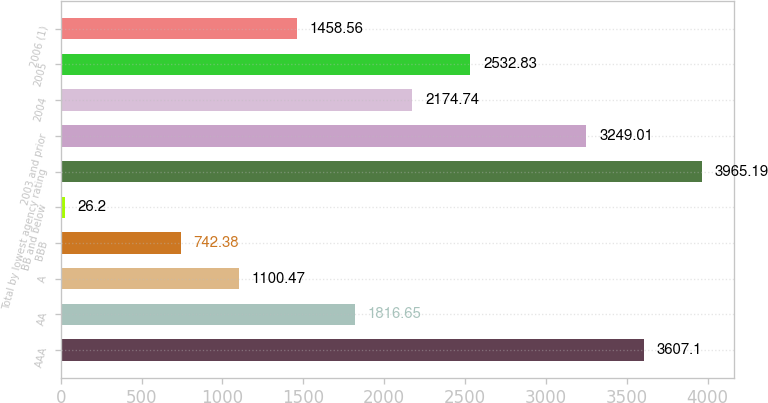<chart> <loc_0><loc_0><loc_500><loc_500><bar_chart><fcel>AAA<fcel>AA<fcel>A<fcel>BBB<fcel>BB and below<fcel>Total by lowest agency rating<fcel>2003 and prior<fcel>2004<fcel>2005<fcel>2006 (1)<nl><fcel>3607.1<fcel>1816.65<fcel>1100.47<fcel>742.38<fcel>26.2<fcel>3965.19<fcel>3249.01<fcel>2174.74<fcel>2532.83<fcel>1458.56<nl></chart> 